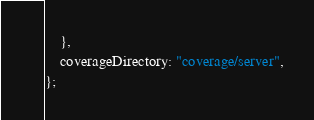Convert code to text. <code><loc_0><loc_0><loc_500><loc_500><_JavaScript_>    },
    coverageDirectory: "coverage/server",
};
</code> 